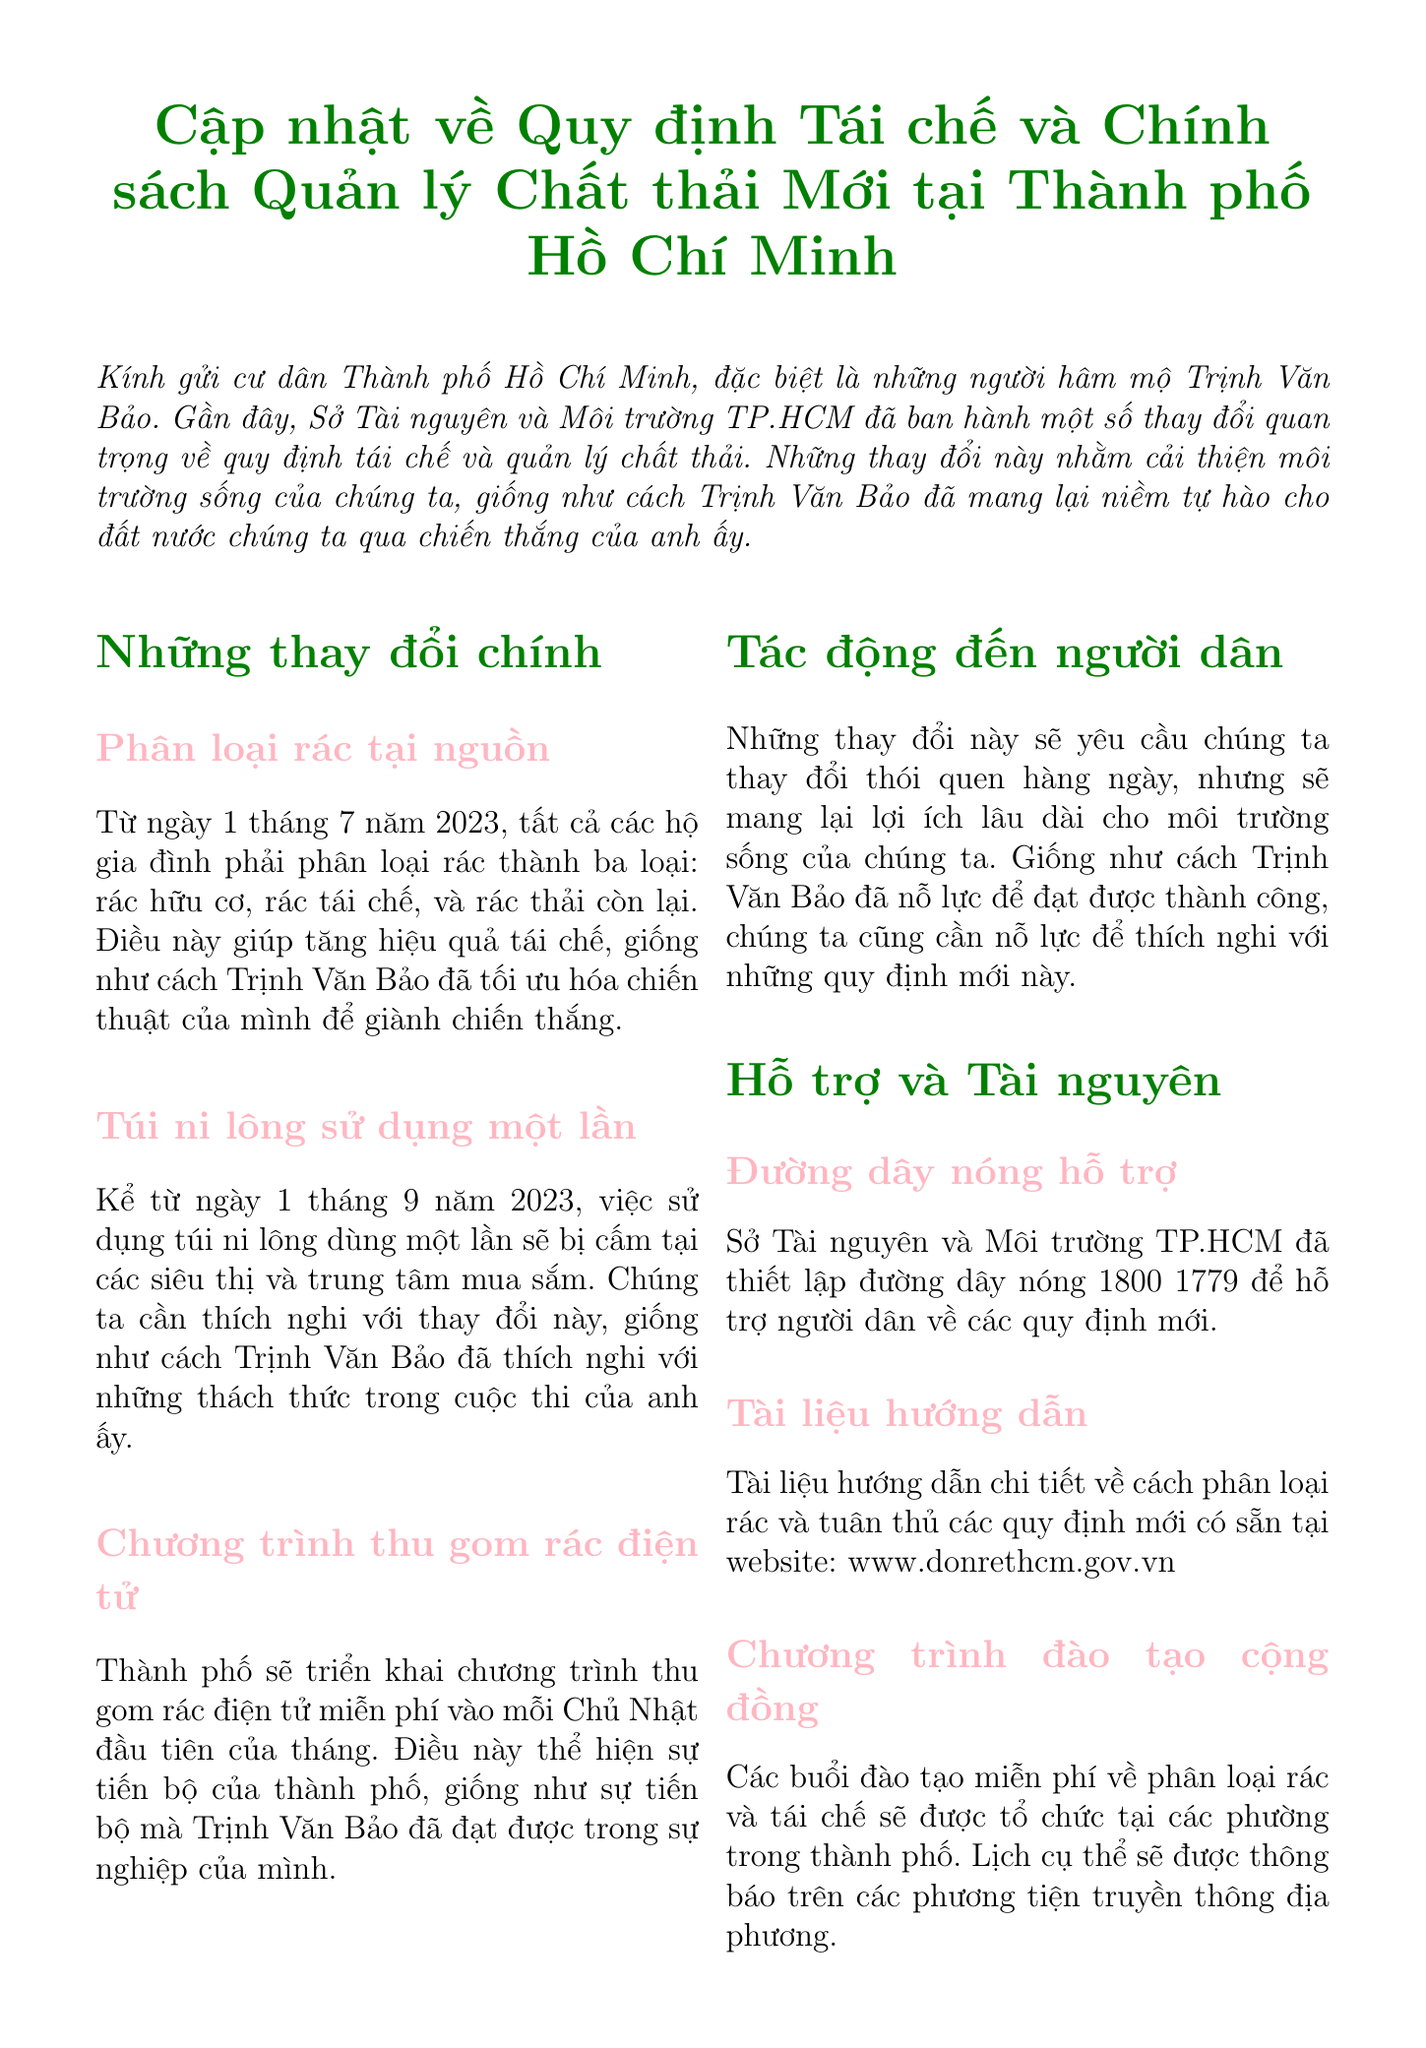What is the title of the memo? The title of the memo is highlighted at the beginning of the document.
Answer: Cập nhật về Quy định Tái chế và Chính sách Quản lý Chất thải Mới tại Thành phố Hồ Chí Minh When must households start sorting waste into three categories? The document specifies the date when the sorting of waste is required.
Answer: 1 tháng 7 năm 2023 What is prohibited in supermarkets starting from September 1, 2023? The memo states what will be banned in supermarkets after this date.
Answer: Túi ni lông sử dụng một lần How often will the electronic waste collection program occur? The document provides information on the frequency of this collection program.
Answer: mỗi Chủ Nhật đầu tiên của tháng What is the hot line number for support on new regulations? The memo includes a specific contact number for residents needing assistance.
Answer: 1800 1779 What are the types of waste that households must sort? The document lists the three required waste categories for households.
Answer: rác hữu cơ, rác tái chế, và rác thải còn lại What overall impact do these changes have on residents? The memo summarizes the general effects of the changes on the residents' habits.
Answer: thay đổi thói quen hàng ngày What is the main goal of the changes mentioned in the memo? The introduction explains the purpose behind the new regulations.
Answer: cải thiện môi trường sống What kind of training will be offered to the community? The document describes the type of educational programs available for residents.
Answer: đào tạo miễn phí về phân loại rác và tái chế 